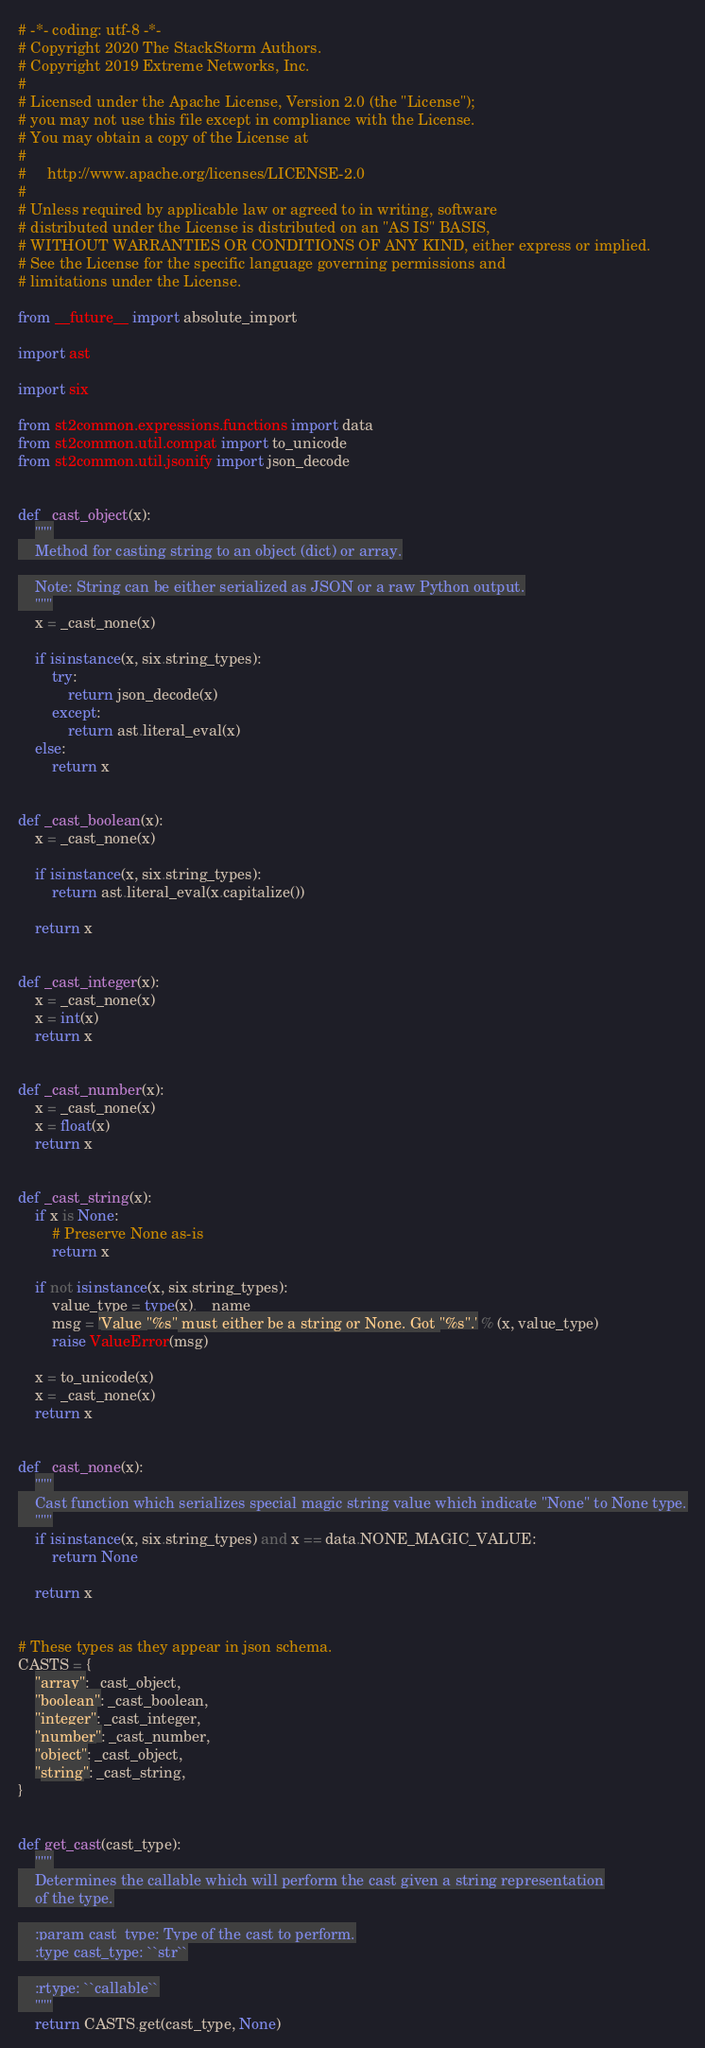<code> <loc_0><loc_0><loc_500><loc_500><_Python_># -*- coding: utf-8 -*-
# Copyright 2020 The StackStorm Authors.
# Copyright 2019 Extreme Networks, Inc.
#
# Licensed under the Apache License, Version 2.0 (the "License");
# you may not use this file except in compliance with the License.
# You may obtain a copy of the License at
#
#     http://www.apache.org/licenses/LICENSE-2.0
#
# Unless required by applicable law or agreed to in writing, software
# distributed under the License is distributed on an "AS IS" BASIS,
# WITHOUT WARRANTIES OR CONDITIONS OF ANY KIND, either express or implied.
# See the License for the specific language governing permissions and
# limitations under the License.

from __future__ import absolute_import

import ast

import six

from st2common.expressions.functions import data
from st2common.util.compat import to_unicode
from st2common.util.jsonify import json_decode


def _cast_object(x):
    """
    Method for casting string to an object (dict) or array.

    Note: String can be either serialized as JSON or a raw Python output.
    """
    x = _cast_none(x)

    if isinstance(x, six.string_types):
        try:
            return json_decode(x)
        except:
            return ast.literal_eval(x)
    else:
        return x


def _cast_boolean(x):
    x = _cast_none(x)

    if isinstance(x, six.string_types):
        return ast.literal_eval(x.capitalize())

    return x


def _cast_integer(x):
    x = _cast_none(x)
    x = int(x)
    return x


def _cast_number(x):
    x = _cast_none(x)
    x = float(x)
    return x


def _cast_string(x):
    if x is None:
        # Preserve None as-is
        return x

    if not isinstance(x, six.string_types):
        value_type = type(x).__name__
        msg = 'Value "%s" must either be a string or None. Got "%s".' % (x, value_type)
        raise ValueError(msg)

    x = to_unicode(x)
    x = _cast_none(x)
    return x


def _cast_none(x):
    """
    Cast function which serializes special magic string value which indicate "None" to None type.
    """
    if isinstance(x, six.string_types) and x == data.NONE_MAGIC_VALUE:
        return None

    return x


# These types as they appear in json schema.
CASTS = {
    "array": _cast_object,
    "boolean": _cast_boolean,
    "integer": _cast_integer,
    "number": _cast_number,
    "object": _cast_object,
    "string": _cast_string,
}


def get_cast(cast_type):
    """
    Determines the callable which will perform the cast given a string representation
    of the type.

    :param cast_type: Type of the cast to perform.
    :type cast_type: ``str``

    :rtype: ``callable``
    """
    return CASTS.get(cast_type, None)
</code> 